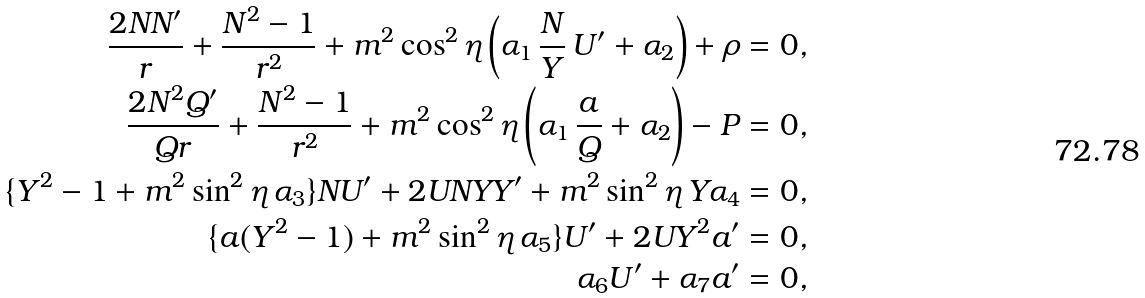<formula> <loc_0><loc_0><loc_500><loc_500>\frac { 2 N N ^ { \prime } } { r } + \frac { N ^ { 2 } - 1 } { r ^ { 2 } } + m ^ { 2 } \cos ^ { 2 } \eta \left ( \alpha _ { 1 } \, \frac { N } { Y } \, U ^ { \prime } + \alpha _ { 2 } \right ) + \rho & = 0 , \\ \frac { 2 N ^ { 2 } Q ^ { \prime } } { Q r } + \frac { N ^ { 2 } - 1 } { r ^ { 2 } } + m ^ { 2 } \cos ^ { 2 } \eta \left ( \alpha _ { 1 } \, \frac { a } { Q } + \alpha _ { 2 } \right ) - P & = 0 , \\ \{ Y ^ { 2 } - 1 + m ^ { 2 } \sin ^ { 2 } \eta \, \alpha _ { 3 } \} N U ^ { \prime } + 2 U N Y Y ^ { \prime } + m ^ { 2 } \sin ^ { 2 } \eta \, Y \alpha _ { 4 } & = 0 , \\ \{ a ( Y ^ { 2 } - 1 ) + m ^ { 2 } \sin ^ { 2 } \eta \, \alpha _ { 5 } \} U ^ { \prime } + 2 U Y ^ { 2 } a ^ { \prime } & = 0 , \\ \alpha _ { 6 } U ^ { \prime } + \alpha _ { 7 } a ^ { \prime } & = 0 ,</formula> 